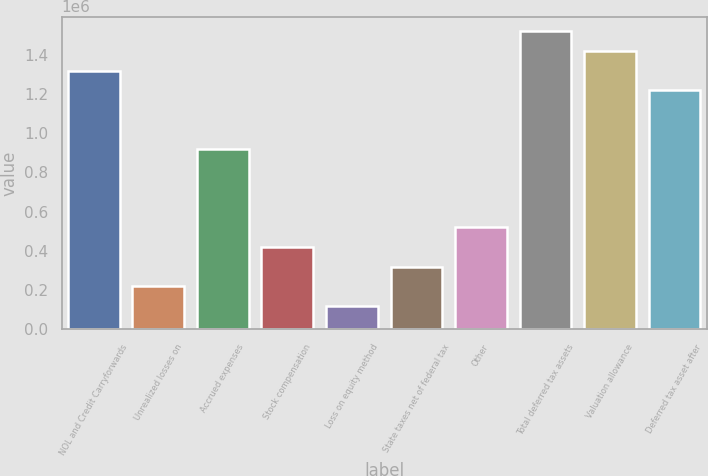Convert chart to OTSL. <chart><loc_0><loc_0><loc_500><loc_500><bar_chart><fcel>NOL and Credit Carryforwards<fcel>Unrealized losses on<fcel>Accrued expenses<fcel>Stock compensation<fcel>Loss on equity method<fcel>State taxes net of federal tax<fcel>Other<fcel>Total deferred tax assets<fcel>Valuation allowance<fcel>Deferred tax asset after<nl><fcel>1.31822e+06<fcel>220390<fcel>919009<fcel>419996<fcel>120588<fcel>320193<fcel>519798<fcel>1.51783e+06<fcel>1.41802e+06<fcel>1.21842e+06<nl></chart> 